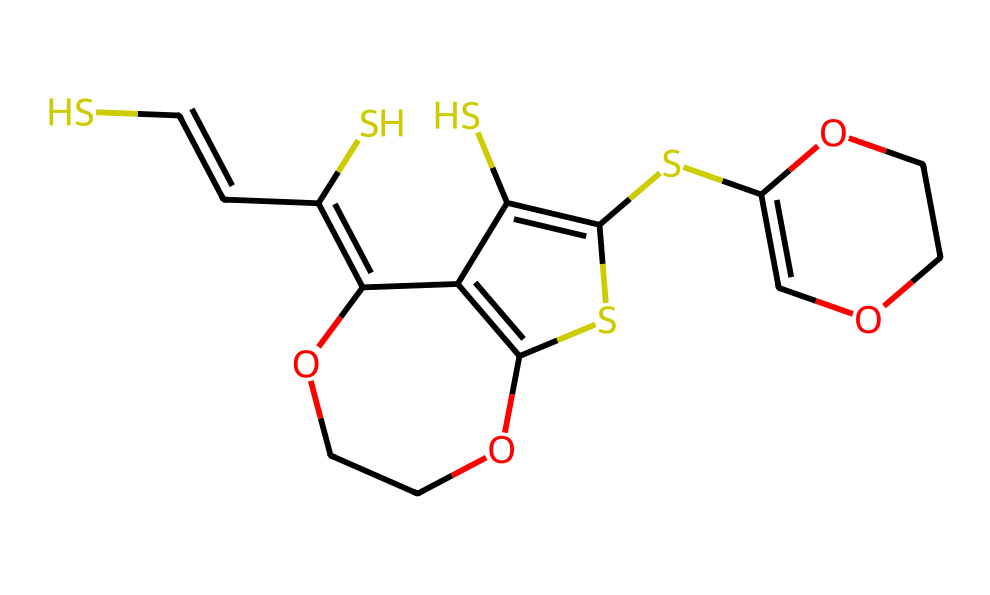What is the total number of carbon atoms in the structure? By examining the SMILES representation, we can count the total carbon (C) atoms present. In this case, there are 12 carbon atoms represented in the structure.
Answer: 12 How many sulfur atoms are in the chemical structure? In the provided SMILES, I can identify three sulfur (S) atoms throughout the structure.
Answer: 3 What type of bonds are predominantly found in this dye? Analyzing the SMILES reveals a significant presence of aromatic structures and double bonds, characteristic of π-bonds in conjugated systems.
Answer: π-bonds What functional groups are present in the chemical structure? The structure includes several hydroxyl (-OH) groups and ether linkages (indicative by the OCC sequences). These functional groups contribute to the conductivity and solubility properties of the dye.
Answer: hydroxyl and ether Is this dye likely to be soluble in water? Given the presence of multiple polar hydroxyl (-OH) groups, this dye is likely to exhibit good solubility in water due to hydrogen bonding capabilities.
Answer: yes How does the presence of sulfur influence the properties of this dye? The sulfur atoms contribute to the dye's electronic properties and may enhance conductivity in flexible electronic applications due to their ability to participate in electron transfer.
Answer: enhances conductivity What is the significance of the ether linkages in this molecular structure? The ether linkages (OCC) provide flexibility and can improve the solubility of the dye in organic solvents, which is important for its application in flexible electronics.
Answer: improves solubility 